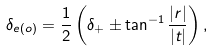<formula> <loc_0><loc_0><loc_500><loc_500>\delta _ { e ( o ) } = \frac { 1 } { 2 } \left ( \delta _ { + } \pm \tan ^ { - 1 } \frac { | r | } { | t | } \right ) ,</formula> 